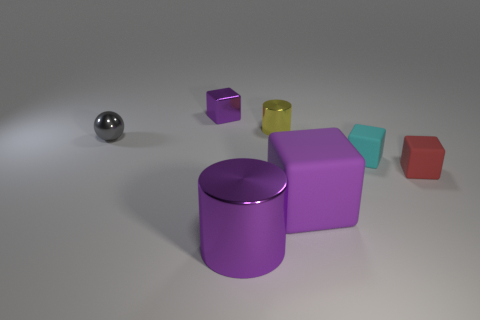Subtract all blue cubes. Subtract all cyan cylinders. How many cubes are left? 4 Add 2 large purple metal cylinders. How many objects exist? 9 Subtract all spheres. How many objects are left? 6 Add 2 small cyan blocks. How many small cyan blocks are left? 3 Add 4 tiny yellow things. How many tiny yellow things exist? 5 Subtract 1 red cubes. How many objects are left? 6 Subtract all large purple rubber cubes. Subtract all tiny metal balls. How many objects are left? 5 